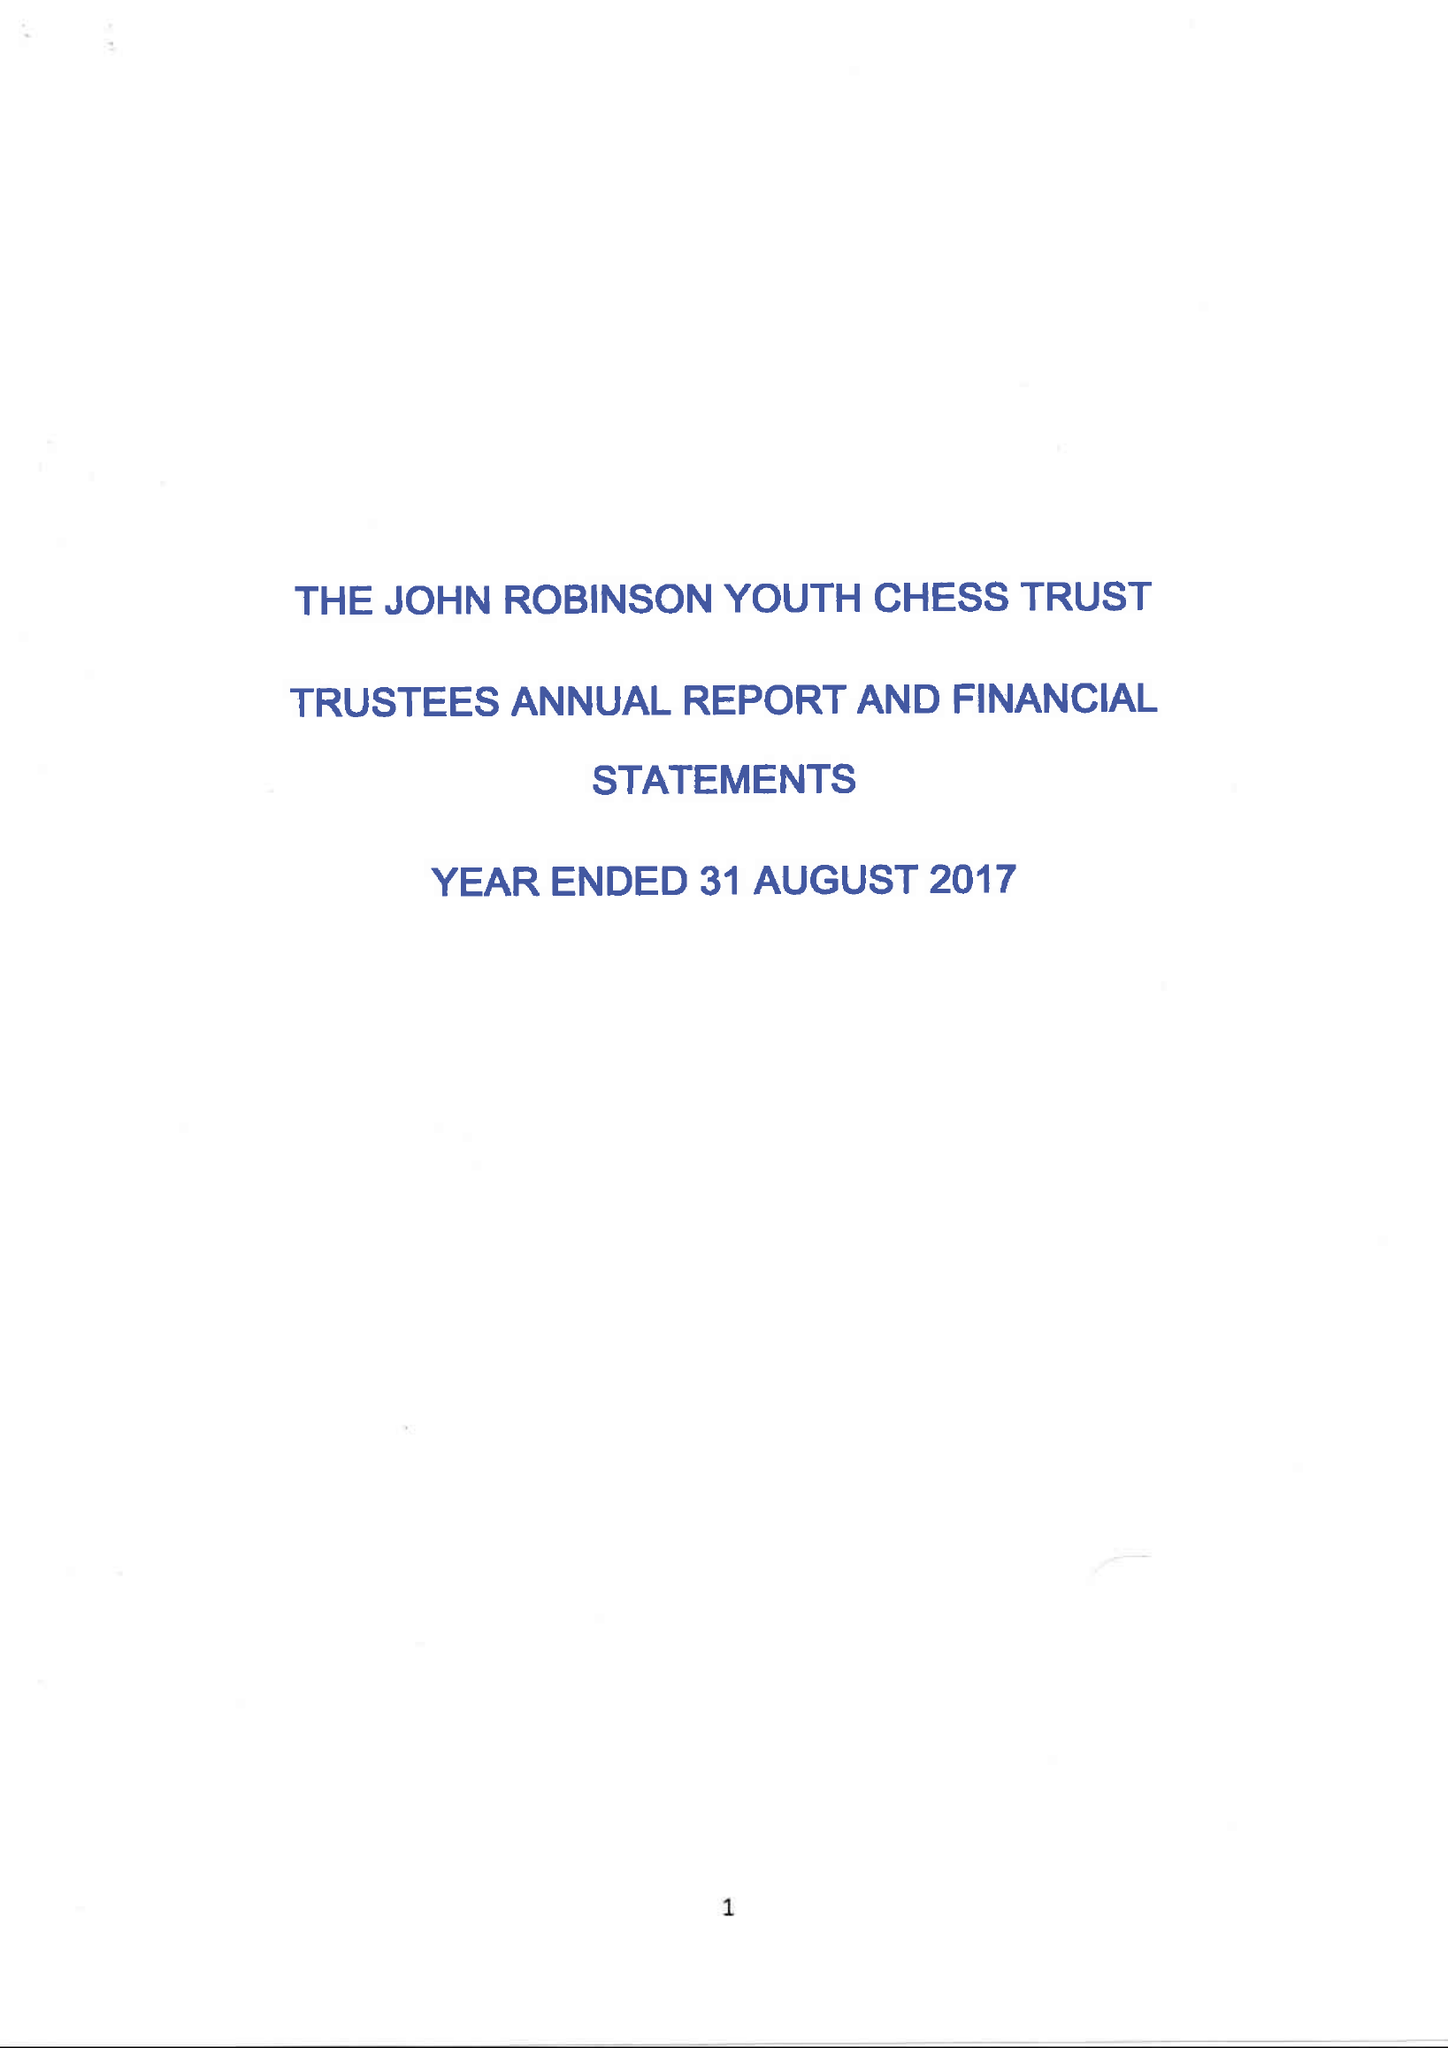What is the value for the charity_number?
Answer the question using a single word or phrase. 1116981 